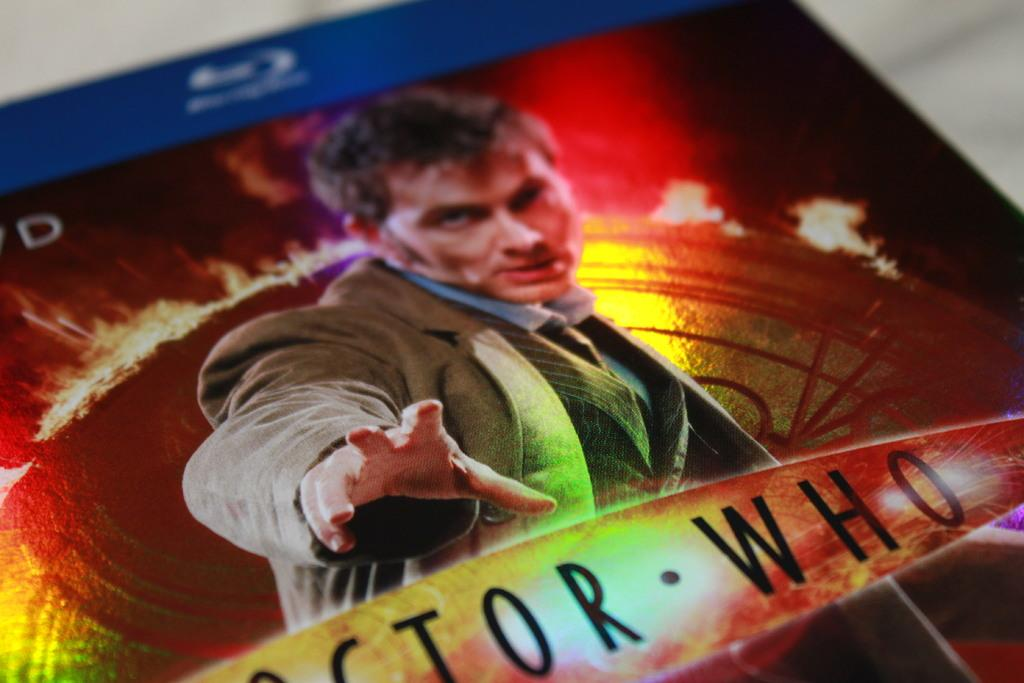<image>
Provide a brief description of the given image. A blu ray case for the show Doctor Who showing an actor on the cover 